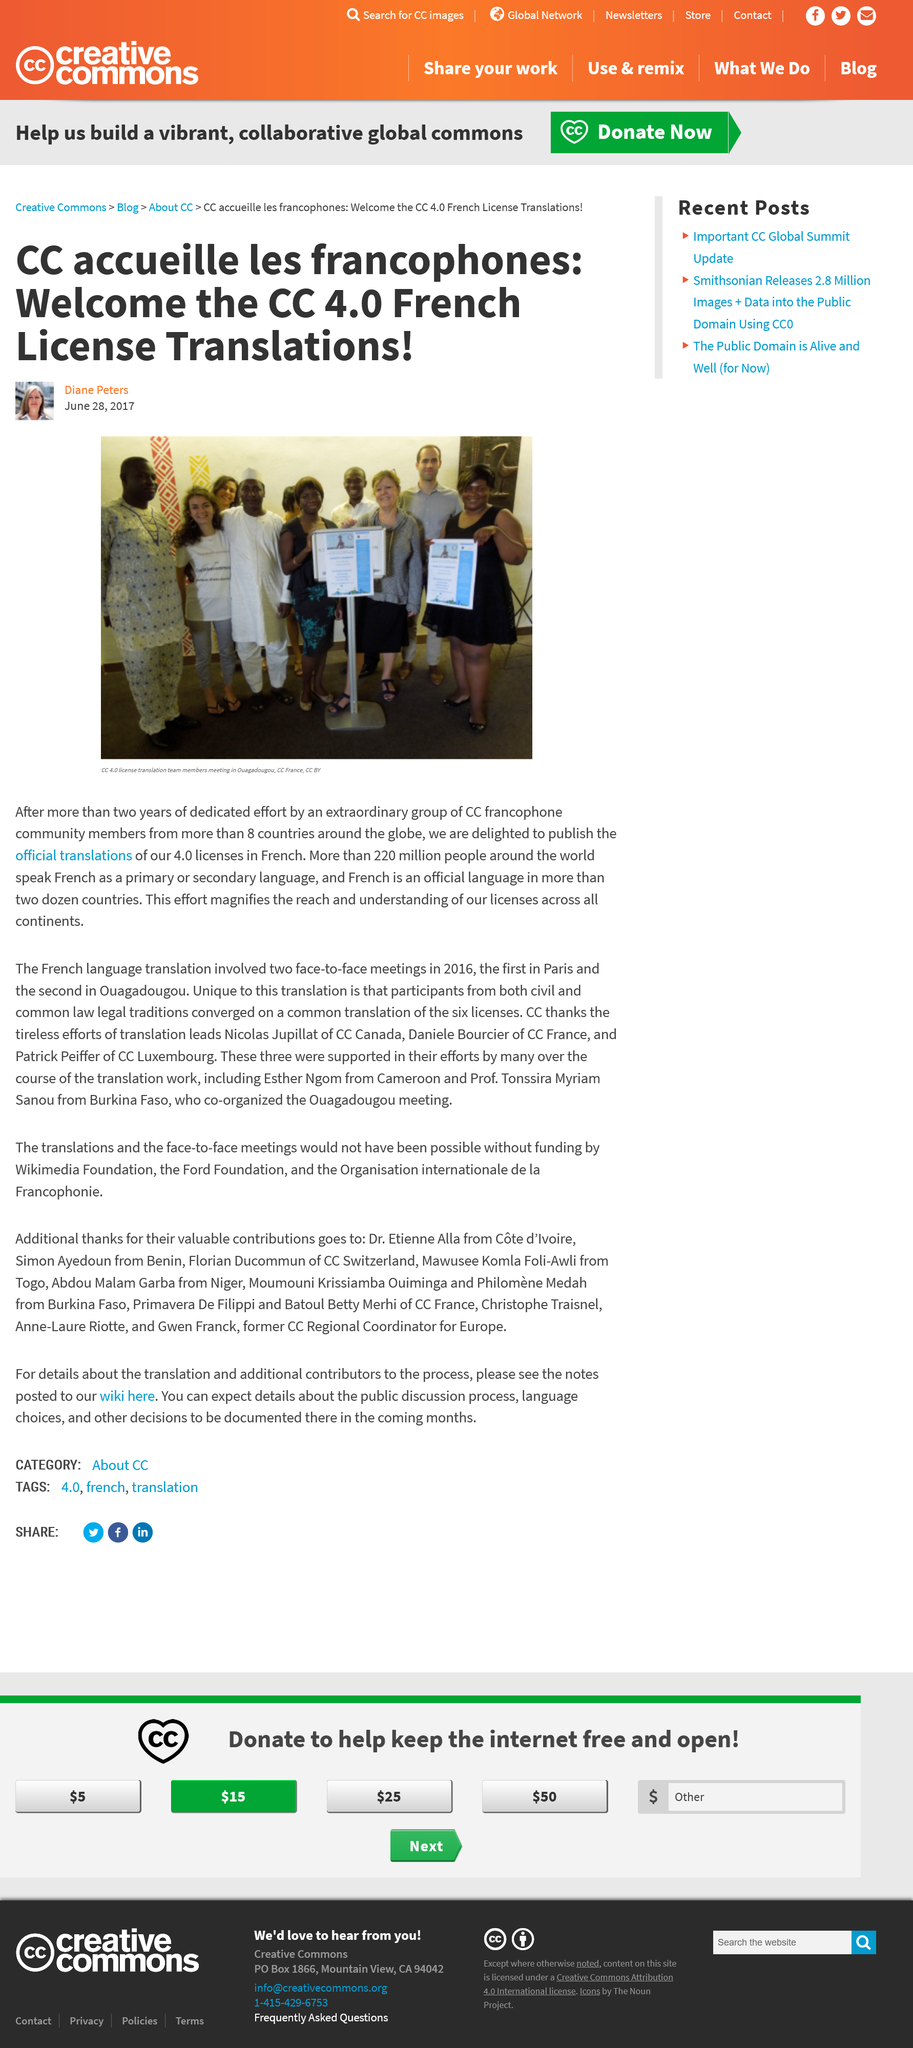Indicate a few pertinent items in this graphic. It is estimated that 220 million people speak French as their primary or secondary language. The author of this article is Diane Peters. The community consisted of members from eight countries, representing various regions and cultures. 